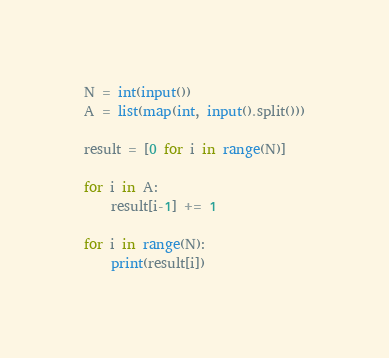<code> <loc_0><loc_0><loc_500><loc_500><_Python_>N = int(input())
A = list(map(int, input().split()))

result = [0 for i in range(N)]

for i in A:
	result[i-1] += 1

for i in range(N):
	print(result[i])</code> 